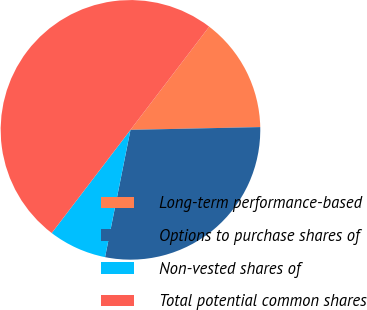<chart> <loc_0><loc_0><loc_500><loc_500><pie_chart><fcel>Long-term performance-based<fcel>Options to purchase shares of<fcel>Non-vested shares of<fcel>Total potential common shares<nl><fcel>14.29%<fcel>28.48%<fcel>7.24%<fcel>50.0%<nl></chart> 